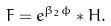<formula> <loc_0><loc_0><loc_500><loc_500>F = e ^ { \beta _ { 2 } \phi } \ast H .</formula> 